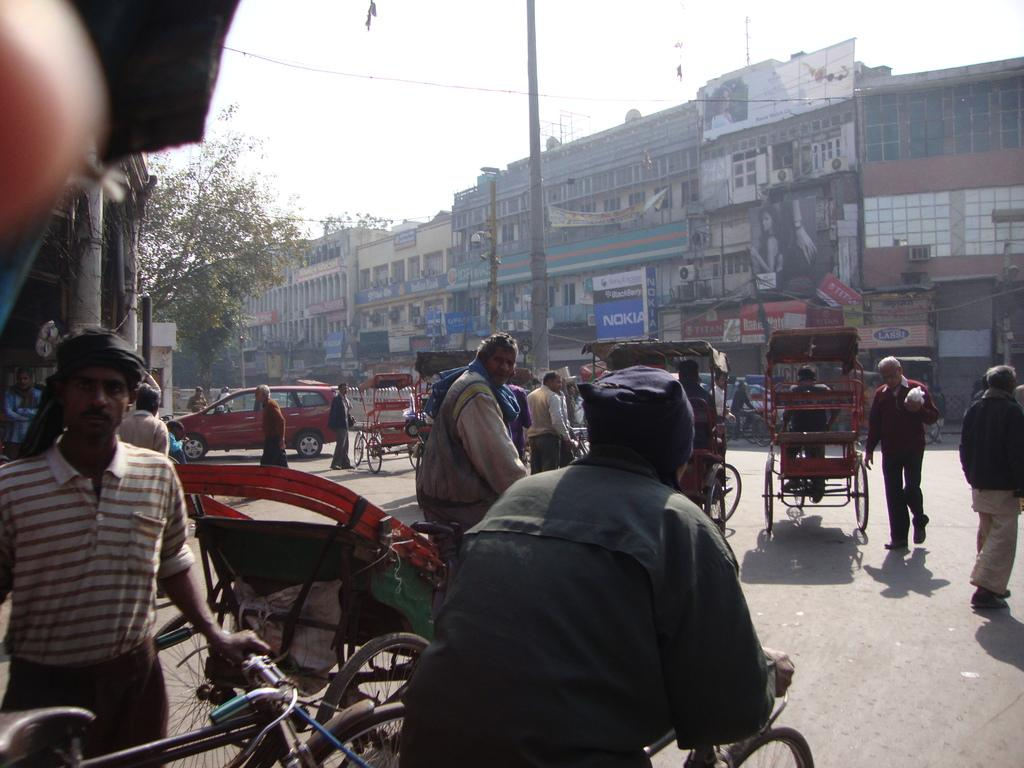What type of view is shown in the image? The image is an outside view. What are the people in the image doing? The people are riding a vehicle. What can be seen in the background of the image? There are buildings in the background. What is located on the left side of the image? There is a tree on the left side of the image. What is visible in the image besides the people and the vehicle? The sky is visible in the image, and there is a pole in the center of the image. What month is it in the image? The image does not provide any information about the month; it only shows an outside view with people riding a vehicle. Can you see any boots in the image? There are no boots visible in the image. 